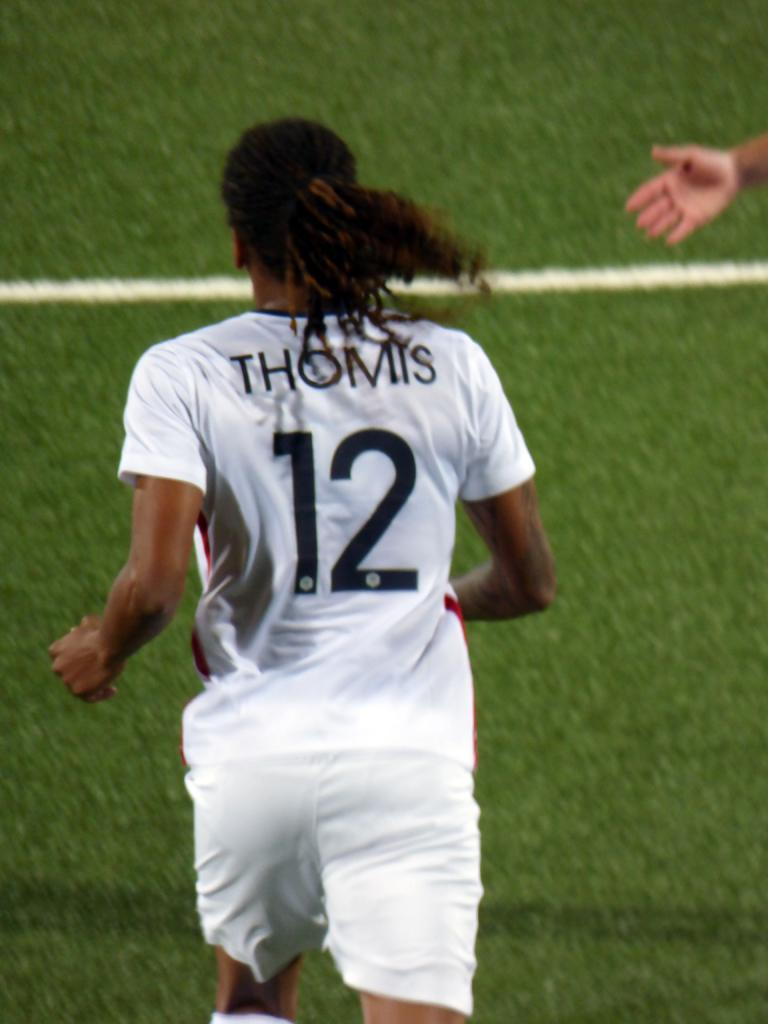<image>
Render a clear and concise summary of the photo. a player that has the number 12 on the back of their jersey 